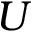Convert formula to latex. <formula><loc_0><loc_0><loc_500><loc_500>U</formula> 